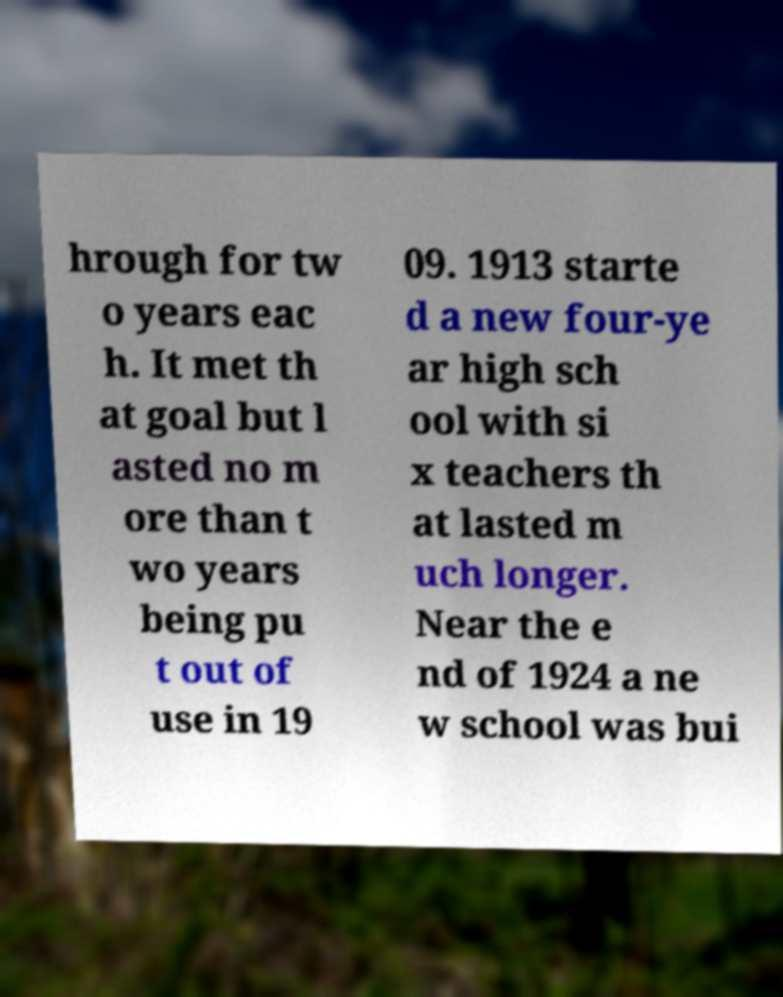What messages or text are displayed in this image? I need them in a readable, typed format. hrough for tw o years eac h. It met th at goal but l asted no m ore than t wo years being pu t out of use in 19 09. 1913 starte d a new four-ye ar high sch ool with si x teachers th at lasted m uch longer. Near the e nd of 1924 a ne w school was bui 